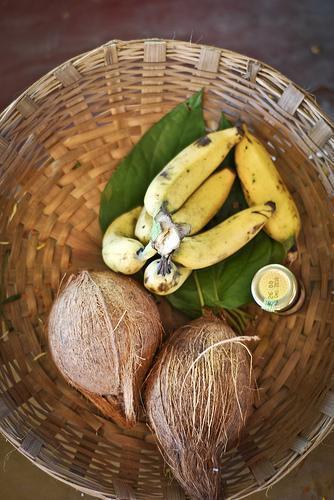How many coconuts are there?
Give a very brief answer. 2. 